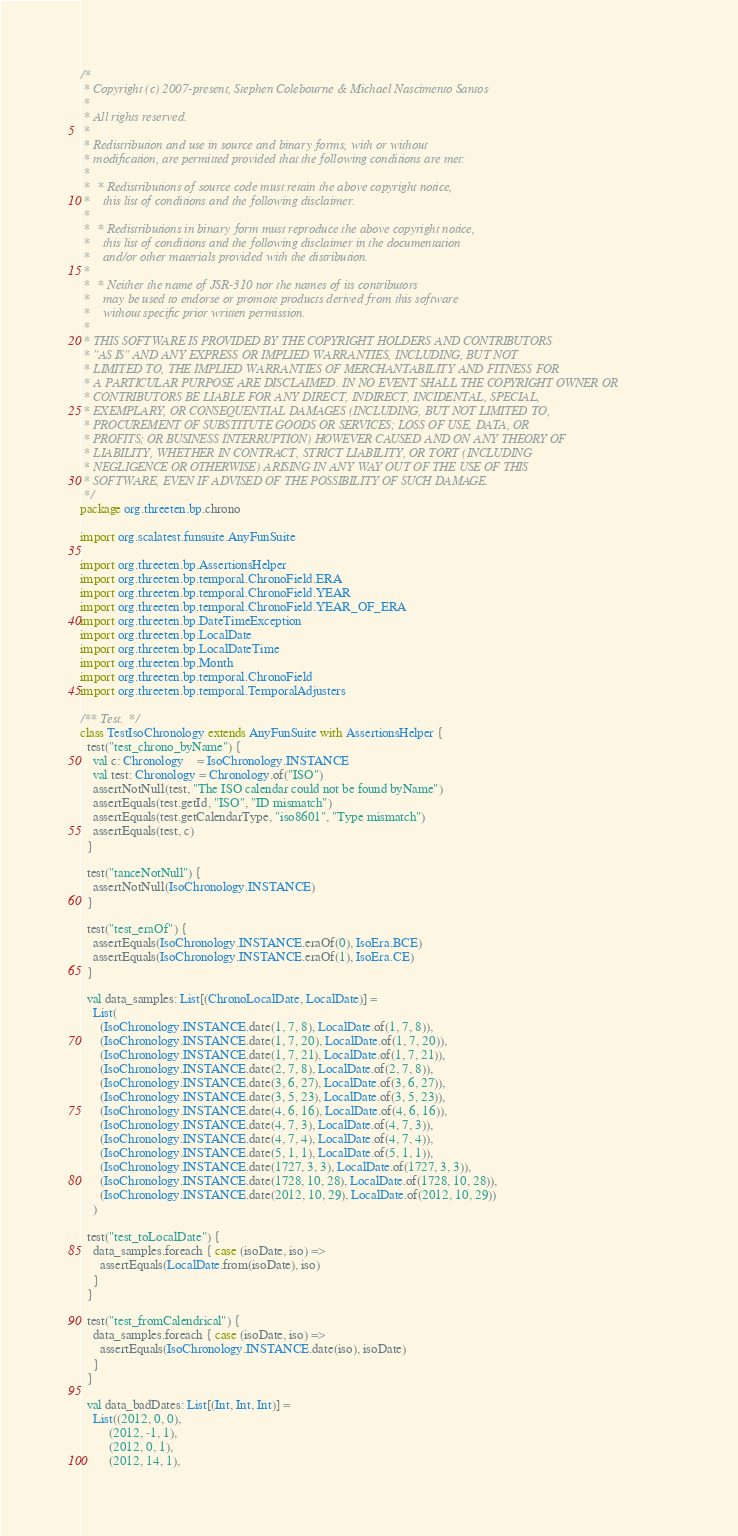<code> <loc_0><loc_0><loc_500><loc_500><_Scala_>/*
 * Copyright (c) 2007-present, Stephen Colebourne & Michael Nascimento Santos
 *
 * All rights reserved.
 *
 * Redistribution and use in source and binary forms, with or without
 * modification, are permitted provided that the following conditions are met:
 *
 *  * Redistributions of source code must retain the above copyright notice,
 *    this list of conditions and the following disclaimer.
 *
 *  * Redistributions in binary form must reproduce the above copyright notice,
 *    this list of conditions and the following disclaimer in the documentation
 *    and/or other materials provided with the distribution.
 *
 *  * Neither the name of JSR-310 nor the names of its contributors
 *    may be used to endorse or promote products derived from this software
 *    without specific prior written permission.
 *
 * THIS SOFTWARE IS PROVIDED BY THE COPYRIGHT HOLDERS AND CONTRIBUTORS
 * "AS IS" AND ANY EXPRESS OR IMPLIED WARRANTIES, INCLUDING, BUT NOT
 * LIMITED TO, THE IMPLIED WARRANTIES OF MERCHANTABILITY AND FITNESS FOR
 * A PARTICULAR PURPOSE ARE DISCLAIMED. IN NO EVENT SHALL THE COPYRIGHT OWNER OR
 * CONTRIBUTORS BE LIABLE FOR ANY DIRECT, INDIRECT, INCIDENTAL, SPECIAL,
 * EXEMPLARY, OR CONSEQUENTIAL DAMAGES (INCLUDING, BUT NOT LIMITED TO,
 * PROCUREMENT OF SUBSTITUTE GOODS OR SERVICES; LOSS OF USE, DATA, OR
 * PROFITS; OR BUSINESS INTERRUPTION) HOWEVER CAUSED AND ON ANY THEORY OF
 * LIABILITY, WHETHER IN CONTRACT, STRICT LIABILITY, OR TORT (INCLUDING
 * NEGLIGENCE OR OTHERWISE) ARISING IN ANY WAY OUT OF THE USE OF THIS
 * SOFTWARE, EVEN IF ADVISED OF THE POSSIBILITY OF SUCH DAMAGE.
 */
package org.threeten.bp.chrono

import org.scalatest.funsuite.AnyFunSuite

import org.threeten.bp.AssertionsHelper
import org.threeten.bp.temporal.ChronoField.ERA
import org.threeten.bp.temporal.ChronoField.YEAR
import org.threeten.bp.temporal.ChronoField.YEAR_OF_ERA
import org.threeten.bp.DateTimeException
import org.threeten.bp.LocalDate
import org.threeten.bp.LocalDateTime
import org.threeten.bp.Month
import org.threeten.bp.temporal.ChronoField
import org.threeten.bp.temporal.TemporalAdjusters

/** Test. */
class TestIsoChronology extends AnyFunSuite with AssertionsHelper {
  test("test_chrono_byName") {
    val c: Chronology    = IsoChronology.INSTANCE
    val test: Chronology = Chronology.of("ISO")
    assertNotNull(test, "The ISO calendar could not be found byName")
    assertEquals(test.getId, "ISO", "ID mismatch")
    assertEquals(test.getCalendarType, "iso8601", "Type mismatch")
    assertEquals(test, c)
  }

  test("tanceNotNull") {
    assertNotNull(IsoChronology.INSTANCE)
  }

  test("test_eraOf") {
    assertEquals(IsoChronology.INSTANCE.eraOf(0), IsoEra.BCE)
    assertEquals(IsoChronology.INSTANCE.eraOf(1), IsoEra.CE)
  }

  val data_samples: List[(ChronoLocalDate, LocalDate)] =
    List(
      (IsoChronology.INSTANCE.date(1, 7, 8), LocalDate.of(1, 7, 8)),
      (IsoChronology.INSTANCE.date(1, 7, 20), LocalDate.of(1, 7, 20)),
      (IsoChronology.INSTANCE.date(1, 7, 21), LocalDate.of(1, 7, 21)),
      (IsoChronology.INSTANCE.date(2, 7, 8), LocalDate.of(2, 7, 8)),
      (IsoChronology.INSTANCE.date(3, 6, 27), LocalDate.of(3, 6, 27)),
      (IsoChronology.INSTANCE.date(3, 5, 23), LocalDate.of(3, 5, 23)),
      (IsoChronology.INSTANCE.date(4, 6, 16), LocalDate.of(4, 6, 16)),
      (IsoChronology.INSTANCE.date(4, 7, 3), LocalDate.of(4, 7, 3)),
      (IsoChronology.INSTANCE.date(4, 7, 4), LocalDate.of(4, 7, 4)),
      (IsoChronology.INSTANCE.date(5, 1, 1), LocalDate.of(5, 1, 1)),
      (IsoChronology.INSTANCE.date(1727, 3, 3), LocalDate.of(1727, 3, 3)),
      (IsoChronology.INSTANCE.date(1728, 10, 28), LocalDate.of(1728, 10, 28)),
      (IsoChronology.INSTANCE.date(2012, 10, 29), LocalDate.of(2012, 10, 29))
    )

  test("test_toLocalDate") {
    data_samples.foreach { case (isoDate, iso) =>
      assertEquals(LocalDate.from(isoDate), iso)
    }
  }

  test("test_fromCalendrical") {
    data_samples.foreach { case (isoDate, iso) =>
      assertEquals(IsoChronology.INSTANCE.date(iso), isoDate)
    }
  }

  val data_badDates: List[(Int, Int, Int)] =
    List((2012, 0, 0),
         (2012, -1, 1),
         (2012, 0, 1),
         (2012, 14, 1),</code> 